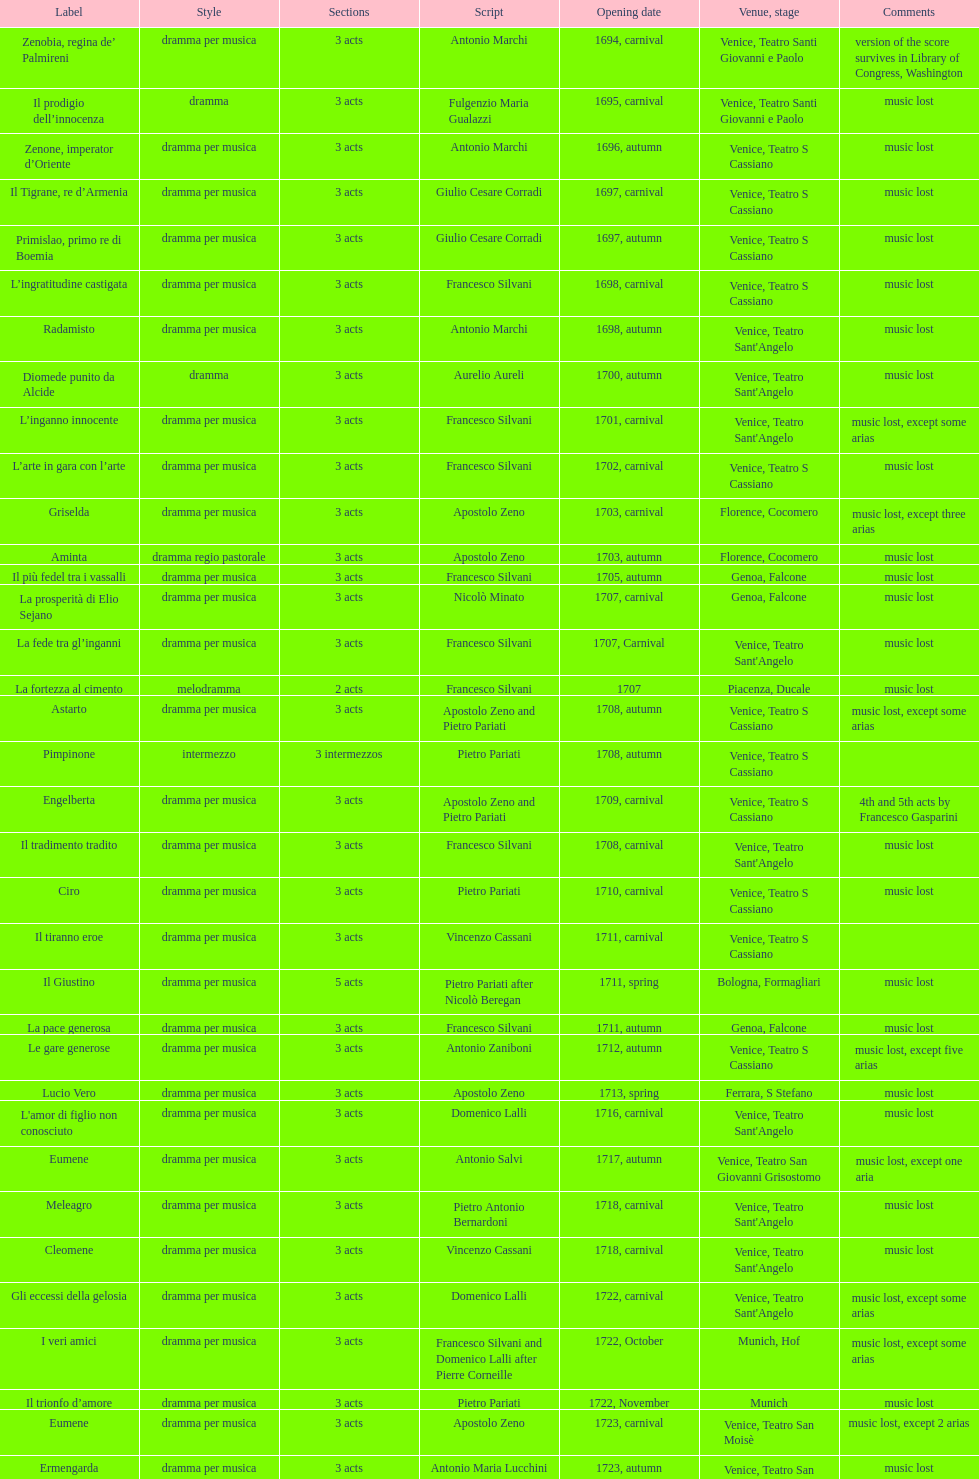Which opera has the most acts, la fortezza al cimento or astarto? Astarto. 